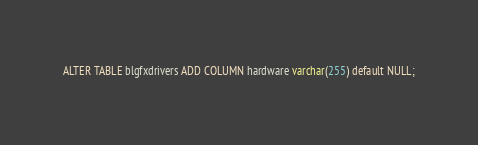<code> <loc_0><loc_0><loc_500><loc_500><_SQL_>ALTER TABLE blgfxdrivers ADD COLUMN hardware varchar(255) default NULL;
</code> 